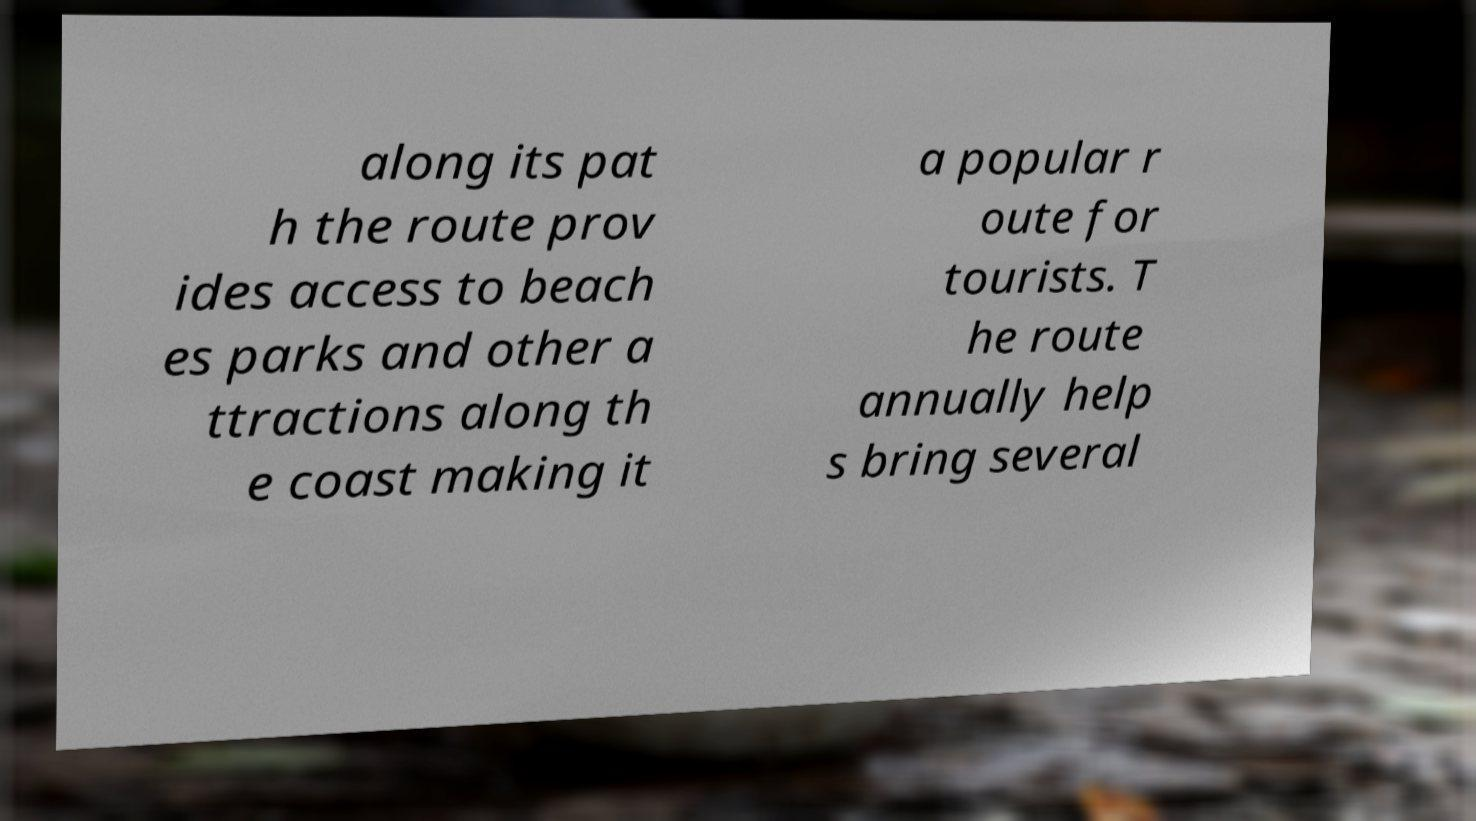For documentation purposes, I need the text within this image transcribed. Could you provide that? along its pat h the route prov ides access to beach es parks and other a ttractions along th e coast making it a popular r oute for tourists. T he route annually help s bring several 